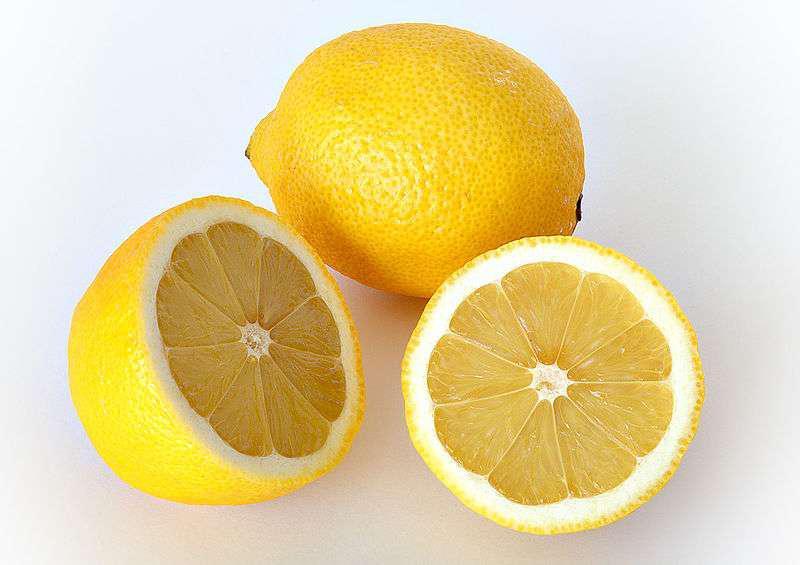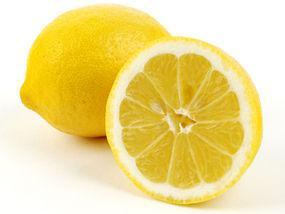The first image is the image on the left, the second image is the image on the right. Examine the images to the left and right. Is the description "There are two whole lemons and three lemon halves." accurate? Answer yes or no. Yes. 